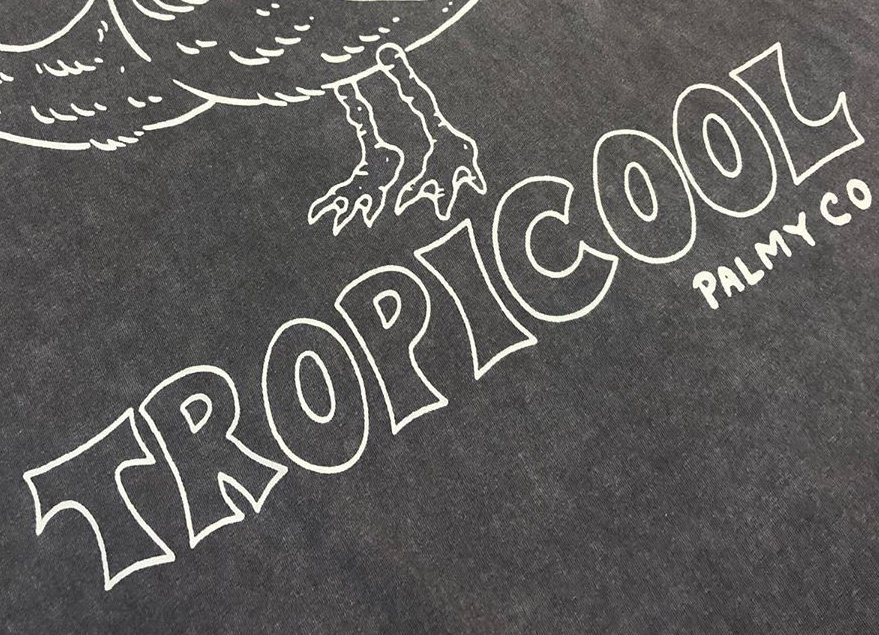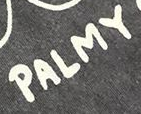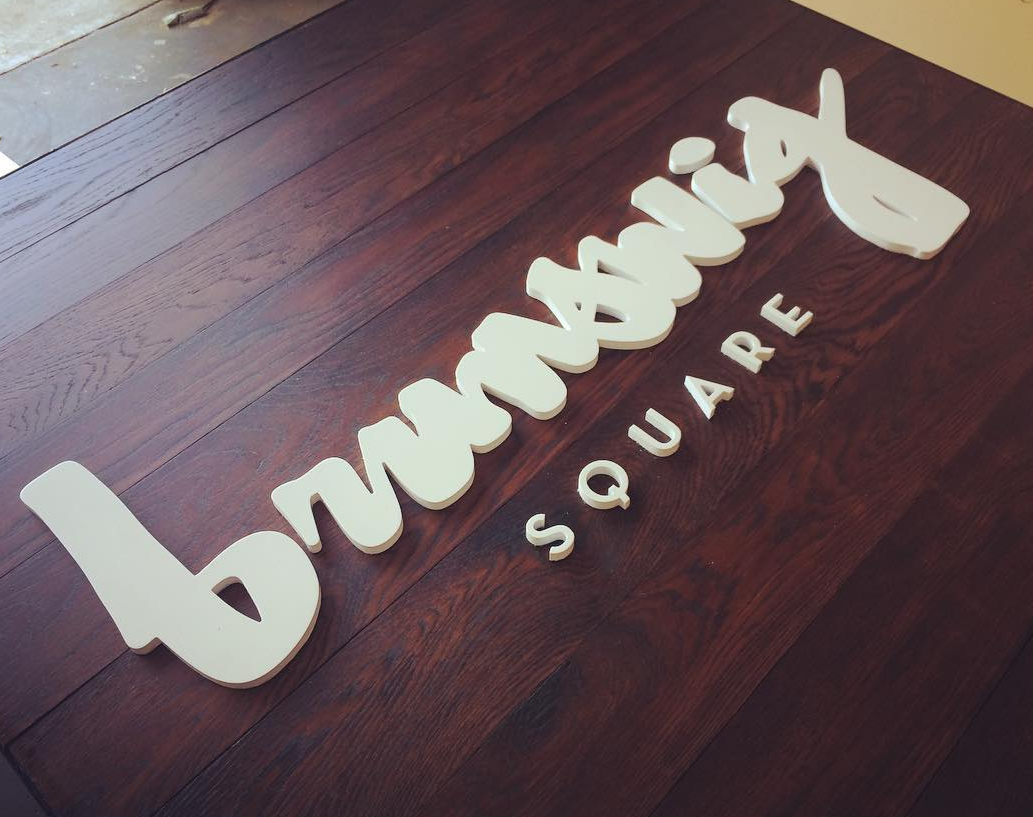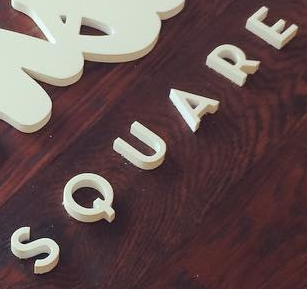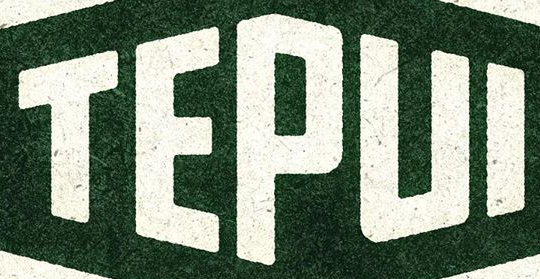What words can you see in these images in sequence, separated by a semicolon? TROPICOOL; PALMY; brunswig; SQUARE; TEPUI 